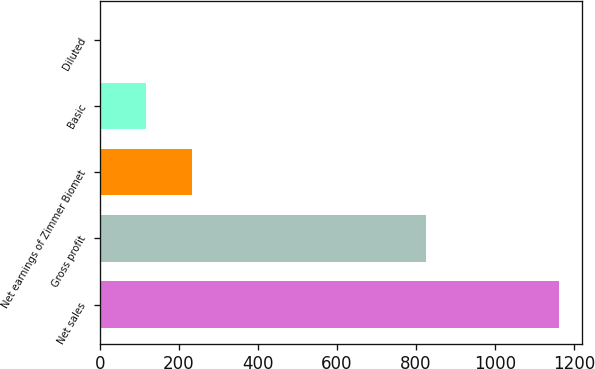Convert chart. <chart><loc_0><loc_0><loc_500><loc_500><bar_chart><fcel>Net sales<fcel>Gross profit<fcel>Net earnings of Zimmer Biomet<fcel>Basic<fcel>Diluted<nl><fcel>1161.5<fcel>826.8<fcel>233.33<fcel>117.31<fcel>1.29<nl></chart> 